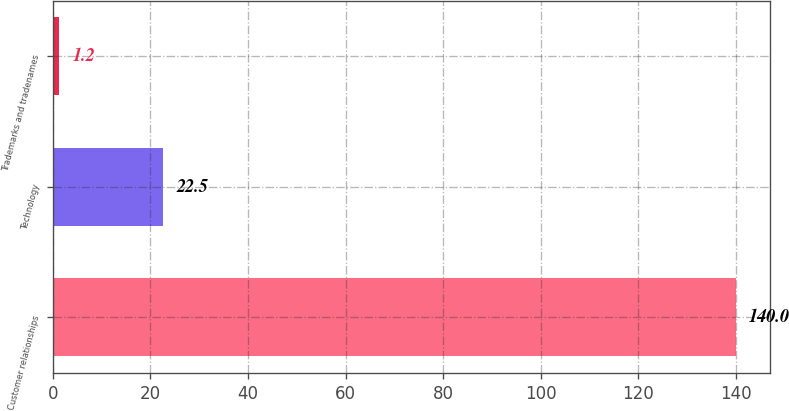Convert chart to OTSL. <chart><loc_0><loc_0><loc_500><loc_500><bar_chart><fcel>Customer relationships<fcel>Technology<fcel>Trademarks and tradenames<nl><fcel>140<fcel>22.5<fcel>1.2<nl></chart> 